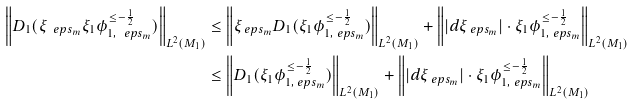Convert formula to latex. <formula><loc_0><loc_0><loc_500><loc_500>\left \| D _ { 1 } ( \xi _ { \ e p s _ { m } } { \xi _ { 1 } } \phi ^ { \leq - \frac { 1 } { 2 } } _ { 1 , { \ e p s _ { m } } } ) \right \| _ { L ^ { 2 } ( M _ { 1 } ) } & \leq \left \| \xi _ { \ e p s _ { m } } D _ { 1 } ( { \xi _ { 1 } } \phi ^ { \leq - \frac { 1 } { 2 } } _ { 1 , { \ e p s _ { m } } } ) \right \| _ { L ^ { 2 } ( M _ { 1 } ) } + \left \| | d \xi _ { \ e p s _ { m } } | \cdot { \xi _ { 1 } } \phi ^ { \leq - \frac { 1 } { 2 } } _ { 1 , { \ e p s _ { m } } } \right \| _ { L ^ { 2 } ( M _ { 1 } ) } \\ & \leq \left \| D _ { 1 } ( { \xi _ { 1 } } \phi ^ { \leq - \frac { 1 } { 2 } } _ { 1 , { \ e p s _ { m } } } ) \right \| _ { L ^ { 2 } ( M _ { 1 } ) } + \left \| | d \xi _ { \ e p s _ { m } } | \cdot { \xi _ { 1 } } \phi ^ { \leq - \frac { 1 } { 2 } } _ { 1 , { \ e p s _ { m } } } \right \| _ { L ^ { 2 } ( M _ { 1 } ) }</formula> 